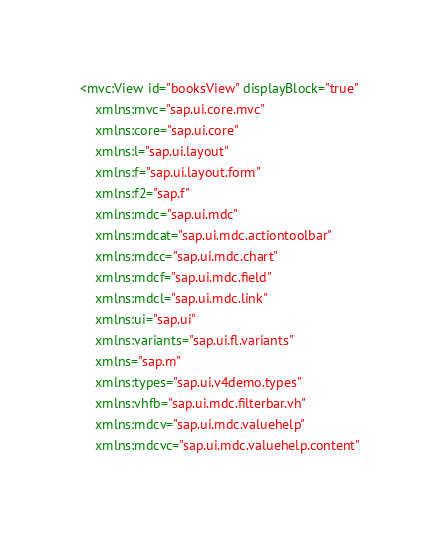Convert code to text. <code><loc_0><loc_0><loc_500><loc_500><_XML_><mvc:View id="booksView" displayBlock="true"
	xmlns:mvc="sap.ui.core.mvc"
	xmlns:core="sap.ui.core"
	xmlns:l="sap.ui.layout"
	xmlns:f="sap.ui.layout.form"
	xmlns:f2="sap.f"
	xmlns:mdc="sap.ui.mdc"
	xmlns:mdcat="sap.ui.mdc.actiontoolbar"
	xmlns:mdcc="sap.ui.mdc.chart"
	xmlns:mdcf="sap.ui.mdc.field"
	xmlns:mdcl="sap.ui.mdc.link"
	xmlns:ui="sap.ui"
	xmlns:variants="sap.ui.fl.variants"
	xmlns="sap.m"
	xmlns:types="sap.ui.v4demo.types"
	xmlns:vhfb="sap.ui.mdc.filterbar.vh"
	xmlns:mdcv="sap.ui.mdc.valuehelp"
	xmlns:mdcvc="sap.ui.mdc.valuehelp.content"</code> 